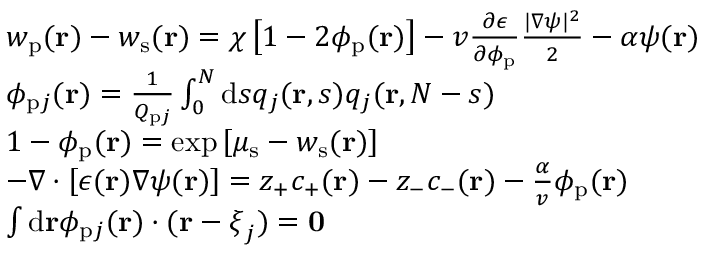<formula> <loc_0><loc_0><loc_500><loc_500>\begin{array} { r l } & { w _ { p } ( r ) - w _ { s } ( r ) = \chi \left [ 1 - 2 \phi _ { p } ( r ) \right ] - v \frac { \partial \epsilon } { \partial \phi _ { p } } \frac { | \nabla \psi | ^ { 2 } } { 2 } - \alpha \psi ( r ) } \\ & { \phi _ { p j } ( r ) = \frac { 1 } { Q _ { p j } } \int _ { 0 } ^ { N } d s q _ { j } ( r , s ) q _ { j } ( r , N - s ) } \\ & { 1 - \phi _ { p } ( r ) = \exp \left [ \mu _ { s } - w _ { s } ( r ) \right ] } \\ & { - \nabla \cdot \left [ \epsilon ( r ) \nabla \psi ( r ) \right ] = z _ { + } c _ { + } ( r ) - z _ { - } c _ { - } ( r ) - \frac { \alpha } { v } \phi _ { p } ( r ) } \\ & { { \int d r \phi _ { p j } ( r ) \cdot ( r - \xi _ { j } ) } = 0 } \end{array}</formula> 